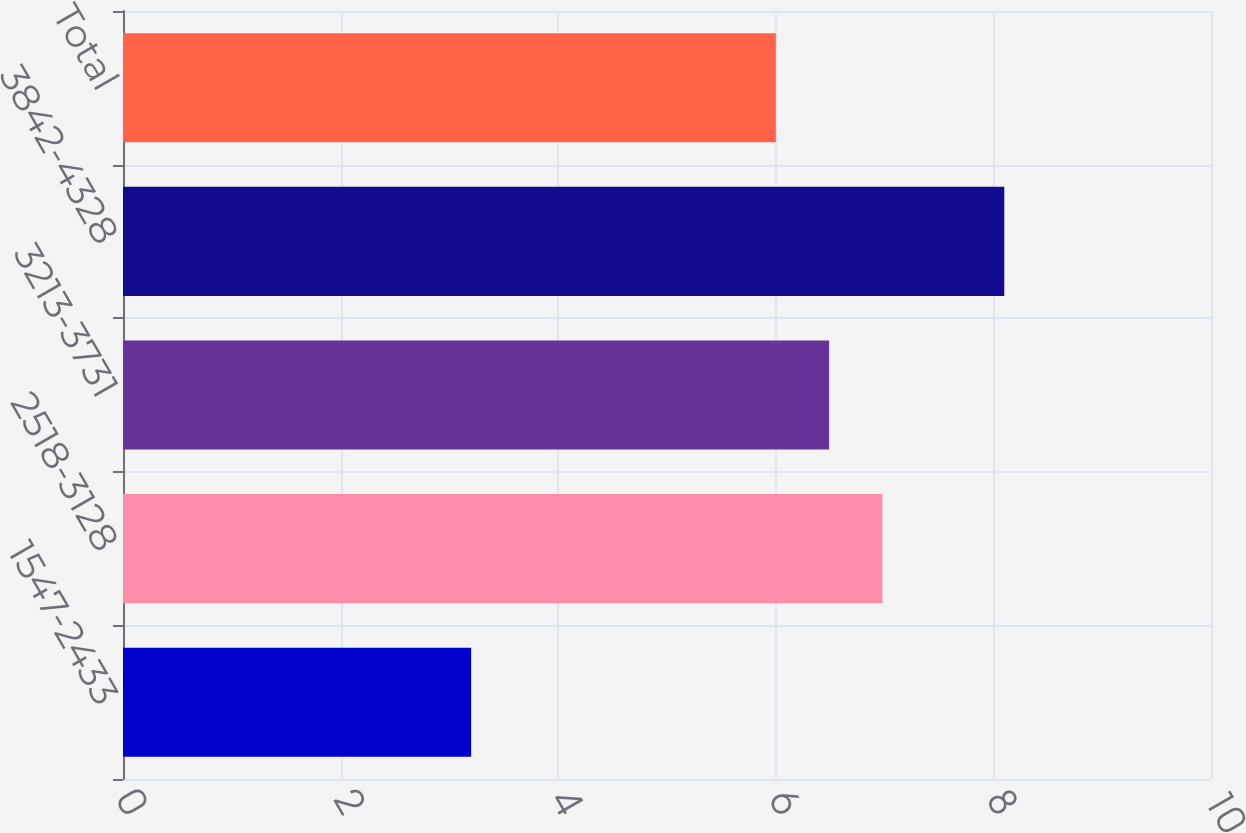Convert chart. <chart><loc_0><loc_0><loc_500><loc_500><bar_chart><fcel>1547-2433<fcel>2518-3128<fcel>3213-3731<fcel>3842-4328<fcel>Total<nl><fcel>3.2<fcel>6.98<fcel>6.49<fcel>8.1<fcel>6<nl></chart> 